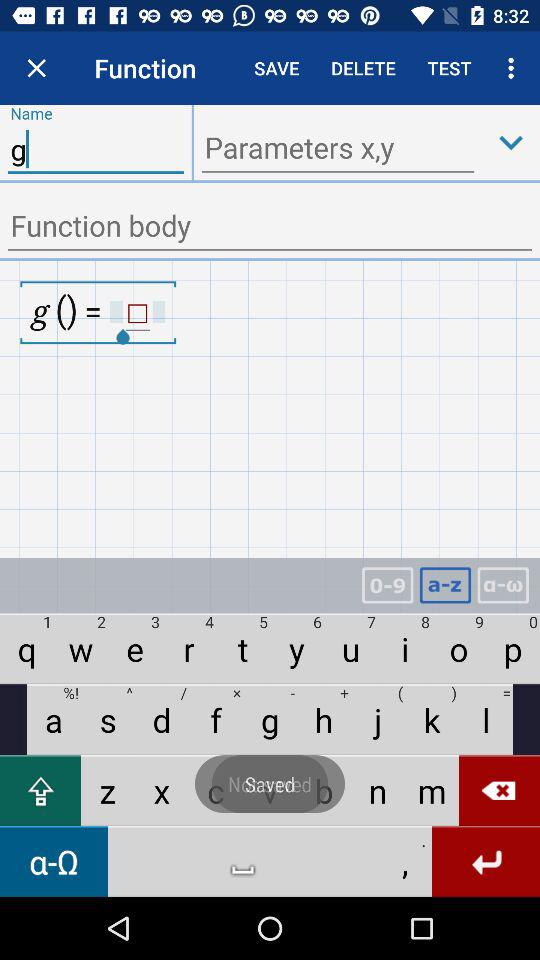What are the parameters? The parameters are x and y. 